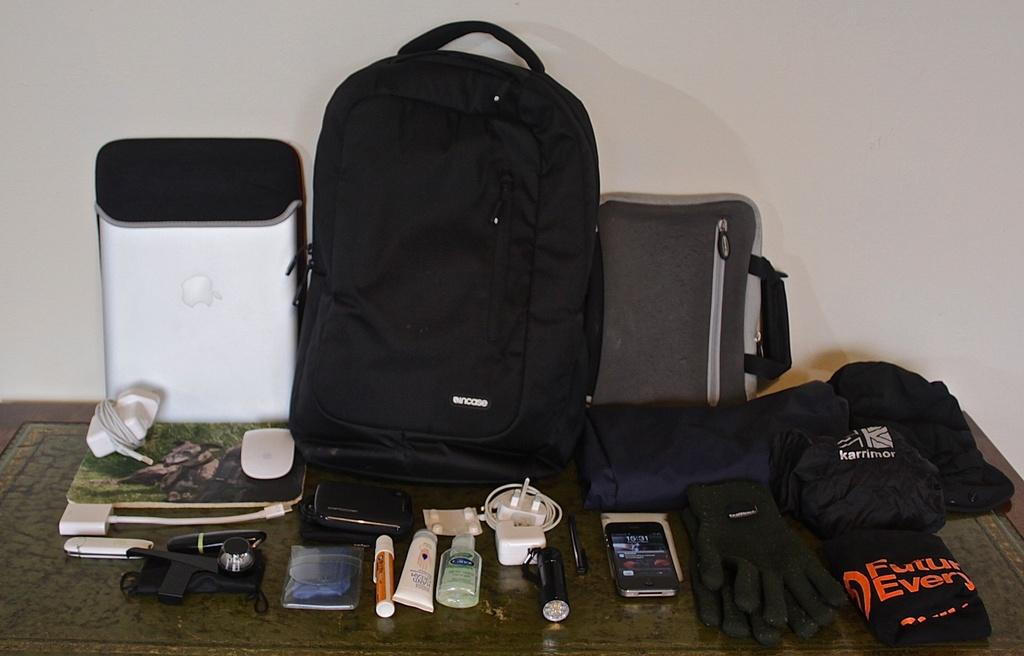What type of items can be seen on the table in the image? There is baggage, clothing, gloves, a mobile, cables, and beauty products on the table in the image. Can you describe the clothing in the image? The clothing in the image consists of gloves. What electronic device is present in the image? There is a mobile in the image. What type of accessories are visible in the image? Cables are visible in the image. What category of products can be seen in the image? Beauty products are present in the image. Is there a canvas in the image that the person is using to paint a landscape? There is no canvas or person painting in the image. Can you see a skateboard being used in the wilderness in the image? There is no skateboard or wilderness depicted in the image. 